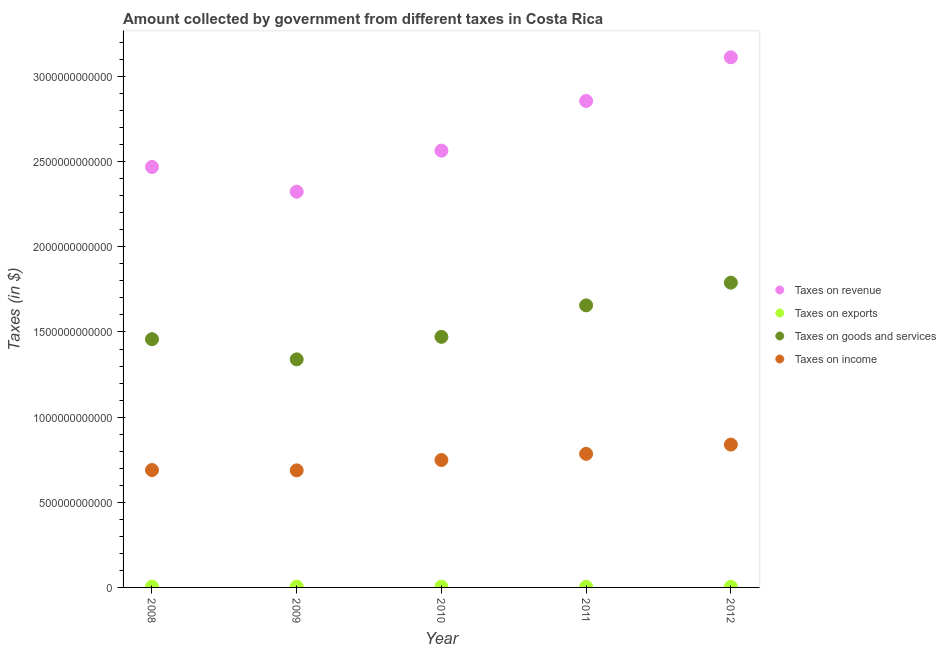Is the number of dotlines equal to the number of legend labels?
Your answer should be compact. Yes. What is the amount collected as tax on income in 2009?
Keep it short and to the point. 6.87e+11. Across all years, what is the maximum amount collected as tax on revenue?
Give a very brief answer. 3.11e+12. Across all years, what is the minimum amount collected as tax on income?
Make the answer very short. 6.87e+11. In which year was the amount collected as tax on goods maximum?
Your answer should be very brief. 2012. In which year was the amount collected as tax on exports minimum?
Offer a very short reply. 2012. What is the total amount collected as tax on income in the graph?
Your answer should be compact. 3.75e+12. What is the difference between the amount collected as tax on revenue in 2009 and that in 2011?
Offer a terse response. -5.33e+11. What is the difference between the amount collected as tax on exports in 2010 and the amount collected as tax on goods in 2008?
Your answer should be compact. -1.45e+12. What is the average amount collected as tax on revenue per year?
Make the answer very short. 2.67e+12. In the year 2009, what is the difference between the amount collected as tax on income and amount collected as tax on revenue?
Offer a terse response. -1.64e+12. In how many years, is the amount collected as tax on exports greater than 1500000000000 $?
Provide a succinct answer. 0. What is the ratio of the amount collected as tax on exports in 2010 to that in 2011?
Offer a terse response. 1. Is the difference between the amount collected as tax on income in 2008 and 2009 greater than the difference between the amount collected as tax on goods in 2008 and 2009?
Offer a very short reply. No. What is the difference between the highest and the second highest amount collected as tax on income?
Make the answer very short. 5.44e+1. What is the difference between the highest and the lowest amount collected as tax on income?
Ensure brevity in your answer.  1.51e+11. Is the sum of the amount collected as tax on income in 2008 and 2012 greater than the maximum amount collected as tax on revenue across all years?
Your answer should be very brief. No. Is it the case that in every year, the sum of the amount collected as tax on exports and amount collected as tax on goods is greater than the sum of amount collected as tax on revenue and amount collected as tax on income?
Provide a succinct answer. No. Does the amount collected as tax on exports monotonically increase over the years?
Offer a terse response. No. Is the amount collected as tax on income strictly greater than the amount collected as tax on goods over the years?
Make the answer very short. No. Is the amount collected as tax on revenue strictly less than the amount collected as tax on income over the years?
Ensure brevity in your answer.  No. What is the difference between two consecutive major ticks on the Y-axis?
Offer a very short reply. 5.00e+11. Are the values on the major ticks of Y-axis written in scientific E-notation?
Ensure brevity in your answer.  No. Does the graph contain any zero values?
Your answer should be compact. No. Does the graph contain grids?
Provide a succinct answer. No. Where does the legend appear in the graph?
Give a very brief answer. Center right. What is the title of the graph?
Your response must be concise. Amount collected by government from different taxes in Costa Rica. What is the label or title of the X-axis?
Give a very brief answer. Year. What is the label or title of the Y-axis?
Make the answer very short. Taxes (in $). What is the Taxes (in $) of Taxes on revenue in 2008?
Your response must be concise. 2.47e+12. What is the Taxes (in $) of Taxes on exports in 2008?
Ensure brevity in your answer.  4.67e+09. What is the Taxes (in $) of Taxes on goods and services in 2008?
Provide a succinct answer. 1.46e+12. What is the Taxes (in $) in Taxes on income in 2008?
Offer a terse response. 6.89e+11. What is the Taxes (in $) of Taxes on revenue in 2009?
Provide a succinct answer. 2.32e+12. What is the Taxes (in $) of Taxes on exports in 2009?
Offer a terse response. 4.68e+09. What is the Taxes (in $) in Taxes on goods and services in 2009?
Provide a succinct answer. 1.34e+12. What is the Taxes (in $) in Taxes on income in 2009?
Give a very brief answer. 6.87e+11. What is the Taxes (in $) in Taxes on revenue in 2010?
Your response must be concise. 2.56e+12. What is the Taxes (in $) in Taxes on exports in 2010?
Provide a succinct answer. 3.97e+09. What is the Taxes (in $) of Taxes on goods and services in 2010?
Keep it short and to the point. 1.47e+12. What is the Taxes (in $) of Taxes on income in 2010?
Your answer should be very brief. 7.48e+11. What is the Taxes (in $) of Taxes on revenue in 2011?
Your answer should be compact. 2.86e+12. What is the Taxes (in $) in Taxes on exports in 2011?
Make the answer very short. 3.99e+09. What is the Taxes (in $) in Taxes on goods and services in 2011?
Make the answer very short. 1.66e+12. What is the Taxes (in $) in Taxes on income in 2011?
Give a very brief answer. 7.84e+11. What is the Taxes (in $) in Taxes on revenue in 2012?
Ensure brevity in your answer.  3.11e+12. What is the Taxes (in $) in Taxes on exports in 2012?
Provide a succinct answer. 3.82e+09. What is the Taxes (in $) in Taxes on goods and services in 2012?
Your response must be concise. 1.79e+12. What is the Taxes (in $) of Taxes on income in 2012?
Make the answer very short. 8.39e+11. Across all years, what is the maximum Taxes (in $) of Taxes on revenue?
Make the answer very short. 3.11e+12. Across all years, what is the maximum Taxes (in $) of Taxes on exports?
Give a very brief answer. 4.68e+09. Across all years, what is the maximum Taxes (in $) in Taxes on goods and services?
Give a very brief answer. 1.79e+12. Across all years, what is the maximum Taxes (in $) in Taxes on income?
Your answer should be compact. 8.39e+11. Across all years, what is the minimum Taxes (in $) of Taxes on revenue?
Your answer should be very brief. 2.32e+12. Across all years, what is the minimum Taxes (in $) in Taxes on exports?
Make the answer very short. 3.82e+09. Across all years, what is the minimum Taxes (in $) of Taxes on goods and services?
Give a very brief answer. 1.34e+12. Across all years, what is the minimum Taxes (in $) of Taxes on income?
Your response must be concise. 6.87e+11. What is the total Taxes (in $) in Taxes on revenue in the graph?
Provide a succinct answer. 1.33e+13. What is the total Taxes (in $) in Taxes on exports in the graph?
Your answer should be compact. 2.11e+1. What is the total Taxes (in $) of Taxes on goods and services in the graph?
Your answer should be compact. 7.71e+12. What is the total Taxes (in $) in Taxes on income in the graph?
Your answer should be compact. 3.75e+12. What is the difference between the Taxes (in $) of Taxes on revenue in 2008 and that in 2009?
Ensure brevity in your answer.  1.45e+11. What is the difference between the Taxes (in $) in Taxes on exports in 2008 and that in 2009?
Provide a succinct answer. -9.87e+06. What is the difference between the Taxes (in $) in Taxes on goods and services in 2008 and that in 2009?
Your response must be concise. 1.18e+11. What is the difference between the Taxes (in $) of Taxes on income in 2008 and that in 2009?
Provide a succinct answer. 1.80e+09. What is the difference between the Taxes (in $) in Taxes on revenue in 2008 and that in 2010?
Provide a succinct answer. -9.58e+1. What is the difference between the Taxes (in $) of Taxes on exports in 2008 and that in 2010?
Offer a very short reply. 6.95e+08. What is the difference between the Taxes (in $) in Taxes on goods and services in 2008 and that in 2010?
Keep it short and to the point. -1.36e+1. What is the difference between the Taxes (in $) of Taxes on income in 2008 and that in 2010?
Make the answer very short. -5.89e+1. What is the difference between the Taxes (in $) in Taxes on revenue in 2008 and that in 2011?
Give a very brief answer. -3.87e+11. What is the difference between the Taxes (in $) of Taxes on exports in 2008 and that in 2011?
Your response must be concise. 6.77e+08. What is the difference between the Taxes (in $) of Taxes on goods and services in 2008 and that in 2011?
Ensure brevity in your answer.  -1.99e+11. What is the difference between the Taxes (in $) of Taxes on income in 2008 and that in 2011?
Provide a short and direct response. -9.52e+1. What is the difference between the Taxes (in $) of Taxes on revenue in 2008 and that in 2012?
Offer a terse response. -6.44e+11. What is the difference between the Taxes (in $) in Taxes on exports in 2008 and that in 2012?
Offer a very short reply. 8.44e+08. What is the difference between the Taxes (in $) in Taxes on goods and services in 2008 and that in 2012?
Provide a succinct answer. -3.32e+11. What is the difference between the Taxes (in $) in Taxes on income in 2008 and that in 2012?
Make the answer very short. -1.50e+11. What is the difference between the Taxes (in $) of Taxes on revenue in 2009 and that in 2010?
Keep it short and to the point. -2.41e+11. What is the difference between the Taxes (in $) of Taxes on exports in 2009 and that in 2010?
Your answer should be compact. 7.04e+08. What is the difference between the Taxes (in $) of Taxes on goods and services in 2009 and that in 2010?
Make the answer very short. -1.32e+11. What is the difference between the Taxes (in $) of Taxes on income in 2009 and that in 2010?
Your answer should be very brief. -6.07e+1. What is the difference between the Taxes (in $) of Taxes on revenue in 2009 and that in 2011?
Provide a short and direct response. -5.33e+11. What is the difference between the Taxes (in $) of Taxes on exports in 2009 and that in 2011?
Your response must be concise. 6.87e+08. What is the difference between the Taxes (in $) of Taxes on goods and services in 2009 and that in 2011?
Ensure brevity in your answer.  -3.17e+11. What is the difference between the Taxes (in $) in Taxes on income in 2009 and that in 2011?
Your answer should be compact. -9.70e+1. What is the difference between the Taxes (in $) in Taxes on revenue in 2009 and that in 2012?
Make the answer very short. -7.89e+11. What is the difference between the Taxes (in $) in Taxes on exports in 2009 and that in 2012?
Provide a short and direct response. 8.54e+08. What is the difference between the Taxes (in $) of Taxes on goods and services in 2009 and that in 2012?
Keep it short and to the point. -4.50e+11. What is the difference between the Taxes (in $) in Taxes on income in 2009 and that in 2012?
Offer a very short reply. -1.51e+11. What is the difference between the Taxes (in $) of Taxes on revenue in 2010 and that in 2011?
Your response must be concise. -2.91e+11. What is the difference between the Taxes (in $) of Taxes on exports in 2010 and that in 2011?
Offer a terse response. -1.76e+07. What is the difference between the Taxes (in $) of Taxes on goods and services in 2010 and that in 2011?
Your response must be concise. -1.85e+11. What is the difference between the Taxes (in $) in Taxes on income in 2010 and that in 2011?
Ensure brevity in your answer.  -3.63e+1. What is the difference between the Taxes (in $) in Taxes on revenue in 2010 and that in 2012?
Make the answer very short. -5.48e+11. What is the difference between the Taxes (in $) in Taxes on exports in 2010 and that in 2012?
Your answer should be very brief. 1.49e+08. What is the difference between the Taxes (in $) in Taxes on goods and services in 2010 and that in 2012?
Offer a terse response. -3.18e+11. What is the difference between the Taxes (in $) of Taxes on income in 2010 and that in 2012?
Provide a short and direct response. -9.07e+1. What is the difference between the Taxes (in $) of Taxes on revenue in 2011 and that in 2012?
Your answer should be compact. -2.57e+11. What is the difference between the Taxes (in $) in Taxes on exports in 2011 and that in 2012?
Keep it short and to the point. 1.67e+08. What is the difference between the Taxes (in $) of Taxes on goods and services in 2011 and that in 2012?
Your response must be concise. -1.33e+11. What is the difference between the Taxes (in $) in Taxes on income in 2011 and that in 2012?
Make the answer very short. -5.44e+1. What is the difference between the Taxes (in $) in Taxes on revenue in 2008 and the Taxes (in $) in Taxes on exports in 2009?
Offer a terse response. 2.46e+12. What is the difference between the Taxes (in $) in Taxes on revenue in 2008 and the Taxes (in $) in Taxes on goods and services in 2009?
Your response must be concise. 1.13e+12. What is the difference between the Taxes (in $) in Taxes on revenue in 2008 and the Taxes (in $) in Taxes on income in 2009?
Keep it short and to the point. 1.78e+12. What is the difference between the Taxes (in $) in Taxes on exports in 2008 and the Taxes (in $) in Taxes on goods and services in 2009?
Provide a succinct answer. -1.33e+12. What is the difference between the Taxes (in $) of Taxes on exports in 2008 and the Taxes (in $) of Taxes on income in 2009?
Your response must be concise. -6.83e+11. What is the difference between the Taxes (in $) of Taxes on goods and services in 2008 and the Taxes (in $) of Taxes on income in 2009?
Provide a succinct answer. 7.70e+11. What is the difference between the Taxes (in $) in Taxes on revenue in 2008 and the Taxes (in $) in Taxes on exports in 2010?
Keep it short and to the point. 2.47e+12. What is the difference between the Taxes (in $) in Taxes on revenue in 2008 and the Taxes (in $) in Taxes on goods and services in 2010?
Ensure brevity in your answer.  9.98e+11. What is the difference between the Taxes (in $) of Taxes on revenue in 2008 and the Taxes (in $) of Taxes on income in 2010?
Your response must be concise. 1.72e+12. What is the difference between the Taxes (in $) of Taxes on exports in 2008 and the Taxes (in $) of Taxes on goods and services in 2010?
Keep it short and to the point. -1.47e+12. What is the difference between the Taxes (in $) in Taxes on exports in 2008 and the Taxes (in $) in Taxes on income in 2010?
Ensure brevity in your answer.  -7.43e+11. What is the difference between the Taxes (in $) of Taxes on goods and services in 2008 and the Taxes (in $) of Taxes on income in 2010?
Offer a very short reply. 7.10e+11. What is the difference between the Taxes (in $) of Taxes on revenue in 2008 and the Taxes (in $) of Taxes on exports in 2011?
Make the answer very short. 2.47e+12. What is the difference between the Taxes (in $) in Taxes on revenue in 2008 and the Taxes (in $) in Taxes on goods and services in 2011?
Your answer should be very brief. 8.13e+11. What is the difference between the Taxes (in $) in Taxes on revenue in 2008 and the Taxes (in $) in Taxes on income in 2011?
Your answer should be very brief. 1.68e+12. What is the difference between the Taxes (in $) of Taxes on exports in 2008 and the Taxes (in $) of Taxes on goods and services in 2011?
Ensure brevity in your answer.  -1.65e+12. What is the difference between the Taxes (in $) of Taxes on exports in 2008 and the Taxes (in $) of Taxes on income in 2011?
Offer a terse response. -7.80e+11. What is the difference between the Taxes (in $) of Taxes on goods and services in 2008 and the Taxes (in $) of Taxes on income in 2011?
Keep it short and to the point. 6.73e+11. What is the difference between the Taxes (in $) in Taxes on revenue in 2008 and the Taxes (in $) in Taxes on exports in 2012?
Make the answer very short. 2.47e+12. What is the difference between the Taxes (in $) in Taxes on revenue in 2008 and the Taxes (in $) in Taxes on goods and services in 2012?
Your response must be concise. 6.79e+11. What is the difference between the Taxes (in $) of Taxes on revenue in 2008 and the Taxes (in $) of Taxes on income in 2012?
Your answer should be very brief. 1.63e+12. What is the difference between the Taxes (in $) of Taxes on exports in 2008 and the Taxes (in $) of Taxes on goods and services in 2012?
Offer a terse response. -1.78e+12. What is the difference between the Taxes (in $) in Taxes on exports in 2008 and the Taxes (in $) in Taxes on income in 2012?
Provide a succinct answer. -8.34e+11. What is the difference between the Taxes (in $) of Taxes on goods and services in 2008 and the Taxes (in $) of Taxes on income in 2012?
Keep it short and to the point. 6.19e+11. What is the difference between the Taxes (in $) in Taxes on revenue in 2009 and the Taxes (in $) in Taxes on exports in 2010?
Offer a terse response. 2.32e+12. What is the difference between the Taxes (in $) of Taxes on revenue in 2009 and the Taxes (in $) of Taxes on goods and services in 2010?
Provide a succinct answer. 8.52e+11. What is the difference between the Taxes (in $) of Taxes on revenue in 2009 and the Taxes (in $) of Taxes on income in 2010?
Offer a very short reply. 1.58e+12. What is the difference between the Taxes (in $) in Taxes on exports in 2009 and the Taxes (in $) in Taxes on goods and services in 2010?
Make the answer very short. -1.47e+12. What is the difference between the Taxes (in $) of Taxes on exports in 2009 and the Taxes (in $) of Taxes on income in 2010?
Provide a succinct answer. -7.43e+11. What is the difference between the Taxes (in $) of Taxes on goods and services in 2009 and the Taxes (in $) of Taxes on income in 2010?
Keep it short and to the point. 5.91e+11. What is the difference between the Taxes (in $) of Taxes on revenue in 2009 and the Taxes (in $) of Taxes on exports in 2011?
Offer a very short reply. 2.32e+12. What is the difference between the Taxes (in $) of Taxes on revenue in 2009 and the Taxes (in $) of Taxes on goods and services in 2011?
Offer a terse response. 6.67e+11. What is the difference between the Taxes (in $) in Taxes on revenue in 2009 and the Taxes (in $) in Taxes on income in 2011?
Your response must be concise. 1.54e+12. What is the difference between the Taxes (in $) in Taxes on exports in 2009 and the Taxes (in $) in Taxes on goods and services in 2011?
Your answer should be compact. -1.65e+12. What is the difference between the Taxes (in $) in Taxes on exports in 2009 and the Taxes (in $) in Taxes on income in 2011?
Provide a succinct answer. -7.80e+11. What is the difference between the Taxes (in $) of Taxes on goods and services in 2009 and the Taxes (in $) of Taxes on income in 2011?
Your answer should be compact. 5.55e+11. What is the difference between the Taxes (in $) of Taxes on revenue in 2009 and the Taxes (in $) of Taxes on exports in 2012?
Provide a succinct answer. 2.32e+12. What is the difference between the Taxes (in $) of Taxes on revenue in 2009 and the Taxes (in $) of Taxes on goods and services in 2012?
Your answer should be compact. 5.34e+11. What is the difference between the Taxes (in $) in Taxes on revenue in 2009 and the Taxes (in $) in Taxes on income in 2012?
Ensure brevity in your answer.  1.48e+12. What is the difference between the Taxes (in $) in Taxes on exports in 2009 and the Taxes (in $) in Taxes on goods and services in 2012?
Provide a short and direct response. -1.78e+12. What is the difference between the Taxes (in $) in Taxes on exports in 2009 and the Taxes (in $) in Taxes on income in 2012?
Keep it short and to the point. -8.34e+11. What is the difference between the Taxes (in $) in Taxes on goods and services in 2009 and the Taxes (in $) in Taxes on income in 2012?
Ensure brevity in your answer.  5.00e+11. What is the difference between the Taxes (in $) of Taxes on revenue in 2010 and the Taxes (in $) of Taxes on exports in 2011?
Make the answer very short. 2.56e+12. What is the difference between the Taxes (in $) of Taxes on revenue in 2010 and the Taxes (in $) of Taxes on goods and services in 2011?
Your answer should be very brief. 9.09e+11. What is the difference between the Taxes (in $) of Taxes on revenue in 2010 and the Taxes (in $) of Taxes on income in 2011?
Ensure brevity in your answer.  1.78e+12. What is the difference between the Taxes (in $) in Taxes on exports in 2010 and the Taxes (in $) in Taxes on goods and services in 2011?
Make the answer very short. -1.65e+12. What is the difference between the Taxes (in $) in Taxes on exports in 2010 and the Taxes (in $) in Taxes on income in 2011?
Ensure brevity in your answer.  -7.80e+11. What is the difference between the Taxes (in $) in Taxes on goods and services in 2010 and the Taxes (in $) in Taxes on income in 2011?
Offer a terse response. 6.87e+11. What is the difference between the Taxes (in $) of Taxes on revenue in 2010 and the Taxes (in $) of Taxes on exports in 2012?
Offer a very short reply. 2.56e+12. What is the difference between the Taxes (in $) of Taxes on revenue in 2010 and the Taxes (in $) of Taxes on goods and services in 2012?
Keep it short and to the point. 7.75e+11. What is the difference between the Taxes (in $) of Taxes on revenue in 2010 and the Taxes (in $) of Taxes on income in 2012?
Keep it short and to the point. 1.73e+12. What is the difference between the Taxes (in $) of Taxes on exports in 2010 and the Taxes (in $) of Taxes on goods and services in 2012?
Your answer should be compact. -1.79e+12. What is the difference between the Taxes (in $) of Taxes on exports in 2010 and the Taxes (in $) of Taxes on income in 2012?
Keep it short and to the point. -8.35e+11. What is the difference between the Taxes (in $) of Taxes on goods and services in 2010 and the Taxes (in $) of Taxes on income in 2012?
Your response must be concise. 6.32e+11. What is the difference between the Taxes (in $) of Taxes on revenue in 2011 and the Taxes (in $) of Taxes on exports in 2012?
Your response must be concise. 2.85e+12. What is the difference between the Taxes (in $) in Taxes on revenue in 2011 and the Taxes (in $) in Taxes on goods and services in 2012?
Your answer should be very brief. 1.07e+12. What is the difference between the Taxes (in $) of Taxes on revenue in 2011 and the Taxes (in $) of Taxes on income in 2012?
Offer a very short reply. 2.02e+12. What is the difference between the Taxes (in $) of Taxes on exports in 2011 and the Taxes (in $) of Taxes on goods and services in 2012?
Give a very brief answer. -1.79e+12. What is the difference between the Taxes (in $) of Taxes on exports in 2011 and the Taxes (in $) of Taxes on income in 2012?
Your answer should be very brief. -8.35e+11. What is the difference between the Taxes (in $) of Taxes on goods and services in 2011 and the Taxes (in $) of Taxes on income in 2012?
Your response must be concise. 8.17e+11. What is the average Taxes (in $) in Taxes on revenue per year?
Ensure brevity in your answer.  2.67e+12. What is the average Taxes (in $) of Taxes on exports per year?
Ensure brevity in your answer.  4.23e+09. What is the average Taxes (in $) of Taxes on goods and services per year?
Offer a very short reply. 1.54e+12. What is the average Taxes (in $) in Taxes on income per year?
Give a very brief answer. 7.50e+11. In the year 2008, what is the difference between the Taxes (in $) in Taxes on revenue and Taxes (in $) in Taxes on exports?
Ensure brevity in your answer.  2.46e+12. In the year 2008, what is the difference between the Taxes (in $) in Taxes on revenue and Taxes (in $) in Taxes on goods and services?
Give a very brief answer. 1.01e+12. In the year 2008, what is the difference between the Taxes (in $) in Taxes on revenue and Taxes (in $) in Taxes on income?
Your answer should be very brief. 1.78e+12. In the year 2008, what is the difference between the Taxes (in $) of Taxes on exports and Taxes (in $) of Taxes on goods and services?
Offer a very short reply. -1.45e+12. In the year 2008, what is the difference between the Taxes (in $) in Taxes on exports and Taxes (in $) in Taxes on income?
Make the answer very short. -6.85e+11. In the year 2008, what is the difference between the Taxes (in $) of Taxes on goods and services and Taxes (in $) of Taxes on income?
Ensure brevity in your answer.  7.68e+11. In the year 2009, what is the difference between the Taxes (in $) in Taxes on revenue and Taxes (in $) in Taxes on exports?
Keep it short and to the point. 2.32e+12. In the year 2009, what is the difference between the Taxes (in $) in Taxes on revenue and Taxes (in $) in Taxes on goods and services?
Make the answer very short. 9.84e+11. In the year 2009, what is the difference between the Taxes (in $) of Taxes on revenue and Taxes (in $) of Taxes on income?
Make the answer very short. 1.64e+12. In the year 2009, what is the difference between the Taxes (in $) of Taxes on exports and Taxes (in $) of Taxes on goods and services?
Offer a very short reply. -1.33e+12. In the year 2009, what is the difference between the Taxes (in $) in Taxes on exports and Taxes (in $) in Taxes on income?
Provide a short and direct response. -6.83e+11. In the year 2009, what is the difference between the Taxes (in $) of Taxes on goods and services and Taxes (in $) of Taxes on income?
Make the answer very short. 6.52e+11. In the year 2010, what is the difference between the Taxes (in $) in Taxes on revenue and Taxes (in $) in Taxes on exports?
Your answer should be compact. 2.56e+12. In the year 2010, what is the difference between the Taxes (in $) of Taxes on revenue and Taxes (in $) of Taxes on goods and services?
Make the answer very short. 1.09e+12. In the year 2010, what is the difference between the Taxes (in $) of Taxes on revenue and Taxes (in $) of Taxes on income?
Provide a succinct answer. 1.82e+12. In the year 2010, what is the difference between the Taxes (in $) in Taxes on exports and Taxes (in $) in Taxes on goods and services?
Provide a succinct answer. -1.47e+12. In the year 2010, what is the difference between the Taxes (in $) in Taxes on exports and Taxes (in $) in Taxes on income?
Provide a succinct answer. -7.44e+11. In the year 2010, what is the difference between the Taxes (in $) in Taxes on goods and services and Taxes (in $) in Taxes on income?
Make the answer very short. 7.23e+11. In the year 2011, what is the difference between the Taxes (in $) in Taxes on revenue and Taxes (in $) in Taxes on exports?
Provide a short and direct response. 2.85e+12. In the year 2011, what is the difference between the Taxes (in $) of Taxes on revenue and Taxes (in $) of Taxes on goods and services?
Keep it short and to the point. 1.20e+12. In the year 2011, what is the difference between the Taxes (in $) of Taxes on revenue and Taxes (in $) of Taxes on income?
Your answer should be compact. 2.07e+12. In the year 2011, what is the difference between the Taxes (in $) of Taxes on exports and Taxes (in $) of Taxes on goods and services?
Make the answer very short. -1.65e+12. In the year 2011, what is the difference between the Taxes (in $) in Taxes on exports and Taxes (in $) in Taxes on income?
Give a very brief answer. -7.80e+11. In the year 2011, what is the difference between the Taxes (in $) in Taxes on goods and services and Taxes (in $) in Taxes on income?
Make the answer very short. 8.72e+11. In the year 2012, what is the difference between the Taxes (in $) of Taxes on revenue and Taxes (in $) of Taxes on exports?
Offer a very short reply. 3.11e+12. In the year 2012, what is the difference between the Taxes (in $) in Taxes on revenue and Taxes (in $) in Taxes on goods and services?
Ensure brevity in your answer.  1.32e+12. In the year 2012, what is the difference between the Taxes (in $) in Taxes on revenue and Taxes (in $) in Taxes on income?
Ensure brevity in your answer.  2.27e+12. In the year 2012, what is the difference between the Taxes (in $) of Taxes on exports and Taxes (in $) of Taxes on goods and services?
Give a very brief answer. -1.79e+12. In the year 2012, what is the difference between the Taxes (in $) in Taxes on exports and Taxes (in $) in Taxes on income?
Your response must be concise. -8.35e+11. In the year 2012, what is the difference between the Taxes (in $) of Taxes on goods and services and Taxes (in $) of Taxes on income?
Your answer should be very brief. 9.51e+11. What is the ratio of the Taxes (in $) of Taxes on revenue in 2008 to that in 2009?
Offer a terse response. 1.06. What is the ratio of the Taxes (in $) in Taxes on goods and services in 2008 to that in 2009?
Offer a very short reply. 1.09. What is the ratio of the Taxes (in $) in Taxes on revenue in 2008 to that in 2010?
Offer a terse response. 0.96. What is the ratio of the Taxes (in $) in Taxes on exports in 2008 to that in 2010?
Provide a short and direct response. 1.17. What is the ratio of the Taxes (in $) in Taxes on income in 2008 to that in 2010?
Keep it short and to the point. 0.92. What is the ratio of the Taxes (in $) of Taxes on revenue in 2008 to that in 2011?
Your answer should be compact. 0.86. What is the ratio of the Taxes (in $) in Taxes on exports in 2008 to that in 2011?
Offer a very short reply. 1.17. What is the ratio of the Taxes (in $) of Taxes on goods and services in 2008 to that in 2011?
Offer a very short reply. 0.88. What is the ratio of the Taxes (in $) in Taxes on income in 2008 to that in 2011?
Give a very brief answer. 0.88. What is the ratio of the Taxes (in $) in Taxes on revenue in 2008 to that in 2012?
Your answer should be very brief. 0.79. What is the ratio of the Taxes (in $) of Taxes on exports in 2008 to that in 2012?
Provide a short and direct response. 1.22. What is the ratio of the Taxes (in $) in Taxes on goods and services in 2008 to that in 2012?
Provide a succinct answer. 0.81. What is the ratio of the Taxes (in $) in Taxes on income in 2008 to that in 2012?
Keep it short and to the point. 0.82. What is the ratio of the Taxes (in $) in Taxes on revenue in 2009 to that in 2010?
Your answer should be compact. 0.91. What is the ratio of the Taxes (in $) in Taxes on exports in 2009 to that in 2010?
Your answer should be very brief. 1.18. What is the ratio of the Taxes (in $) of Taxes on goods and services in 2009 to that in 2010?
Keep it short and to the point. 0.91. What is the ratio of the Taxes (in $) of Taxes on income in 2009 to that in 2010?
Your answer should be compact. 0.92. What is the ratio of the Taxes (in $) of Taxes on revenue in 2009 to that in 2011?
Provide a succinct answer. 0.81. What is the ratio of the Taxes (in $) of Taxes on exports in 2009 to that in 2011?
Make the answer very short. 1.17. What is the ratio of the Taxes (in $) of Taxes on goods and services in 2009 to that in 2011?
Make the answer very short. 0.81. What is the ratio of the Taxes (in $) of Taxes on income in 2009 to that in 2011?
Keep it short and to the point. 0.88. What is the ratio of the Taxes (in $) of Taxes on revenue in 2009 to that in 2012?
Keep it short and to the point. 0.75. What is the ratio of the Taxes (in $) in Taxes on exports in 2009 to that in 2012?
Provide a short and direct response. 1.22. What is the ratio of the Taxes (in $) of Taxes on goods and services in 2009 to that in 2012?
Provide a short and direct response. 0.75. What is the ratio of the Taxes (in $) of Taxes on income in 2009 to that in 2012?
Ensure brevity in your answer.  0.82. What is the ratio of the Taxes (in $) of Taxes on revenue in 2010 to that in 2011?
Ensure brevity in your answer.  0.9. What is the ratio of the Taxes (in $) in Taxes on goods and services in 2010 to that in 2011?
Provide a short and direct response. 0.89. What is the ratio of the Taxes (in $) of Taxes on income in 2010 to that in 2011?
Your response must be concise. 0.95. What is the ratio of the Taxes (in $) in Taxes on revenue in 2010 to that in 2012?
Your answer should be very brief. 0.82. What is the ratio of the Taxes (in $) in Taxes on exports in 2010 to that in 2012?
Make the answer very short. 1.04. What is the ratio of the Taxes (in $) of Taxes on goods and services in 2010 to that in 2012?
Make the answer very short. 0.82. What is the ratio of the Taxes (in $) of Taxes on income in 2010 to that in 2012?
Offer a terse response. 0.89. What is the ratio of the Taxes (in $) of Taxes on revenue in 2011 to that in 2012?
Provide a succinct answer. 0.92. What is the ratio of the Taxes (in $) of Taxes on exports in 2011 to that in 2012?
Your answer should be very brief. 1.04. What is the ratio of the Taxes (in $) of Taxes on goods and services in 2011 to that in 2012?
Provide a short and direct response. 0.93. What is the ratio of the Taxes (in $) of Taxes on income in 2011 to that in 2012?
Provide a succinct answer. 0.94. What is the difference between the highest and the second highest Taxes (in $) in Taxes on revenue?
Offer a very short reply. 2.57e+11. What is the difference between the highest and the second highest Taxes (in $) in Taxes on exports?
Provide a succinct answer. 9.87e+06. What is the difference between the highest and the second highest Taxes (in $) in Taxes on goods and services?
Provide a short and direct response. 1.33e+11. What is the difference between the highest and the second highest Taxes (in $) in Taxes on income?
Give a very brief answer. 5.44e+1. What is the difference between the highest and the lowest Taxes (in $) in Taxes on revenue?
Offer a terse response. 7.89e+11. What is the difference between the highest and the lowest Taxes (in $) of Taxes on exports?
Provide a succinct answer. 8.54e+08. What is the difference between the highest and the lowest Taxes (in $) in Taxes on goods and services?
Offer a terse response. 4.50e+11. What is the difference between the highest and the lowest Taxes (in $) in Taxes on income?
Offer a terse response. 1.51e+11. 